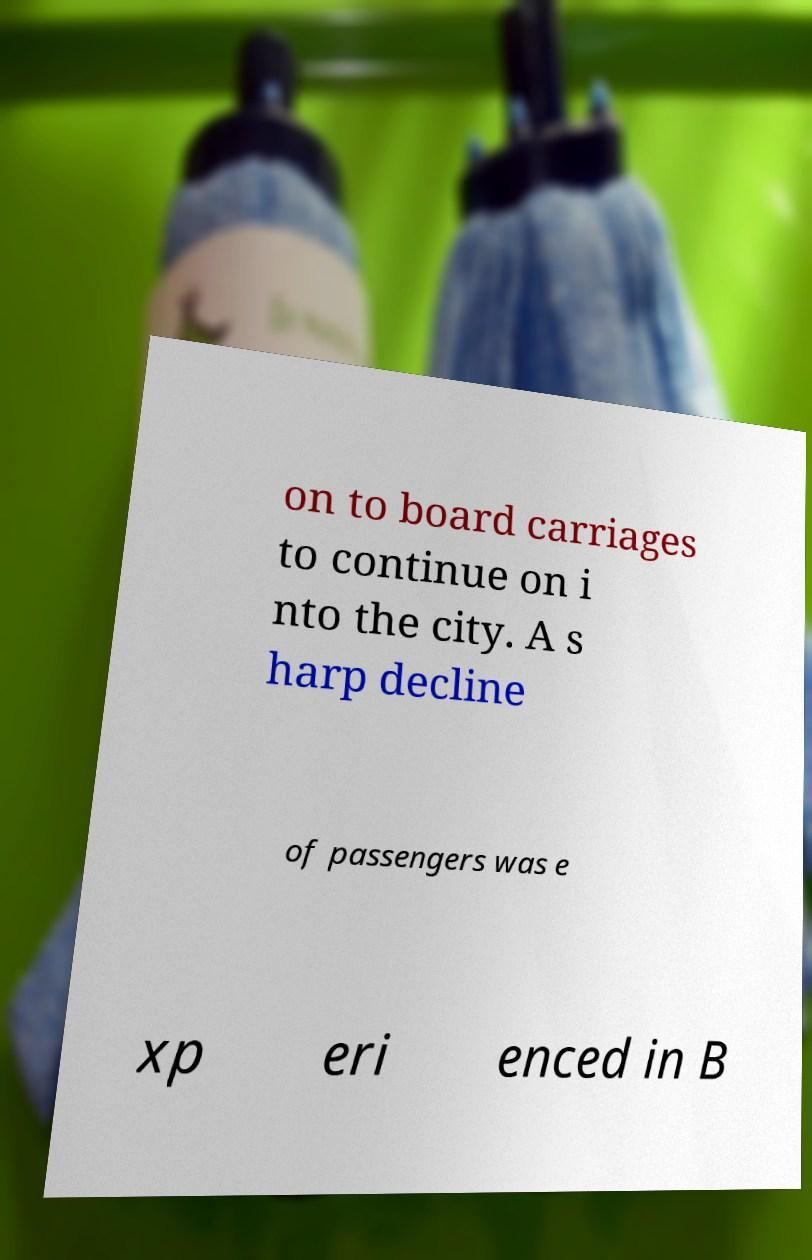Please read and relay the text visible in this image. What does it say? on to board carriages to continue on i nto the city. A s harp decline of passengers was e xp eri enced in B 